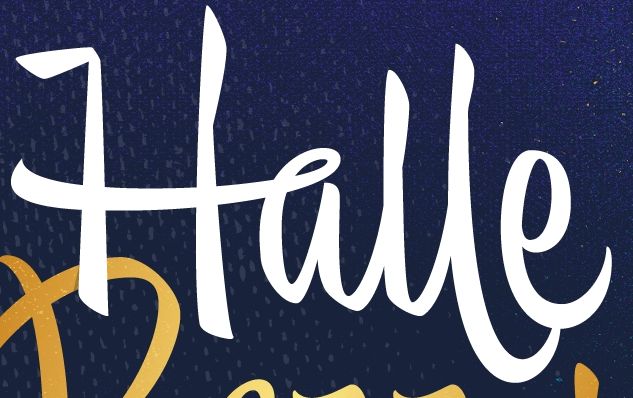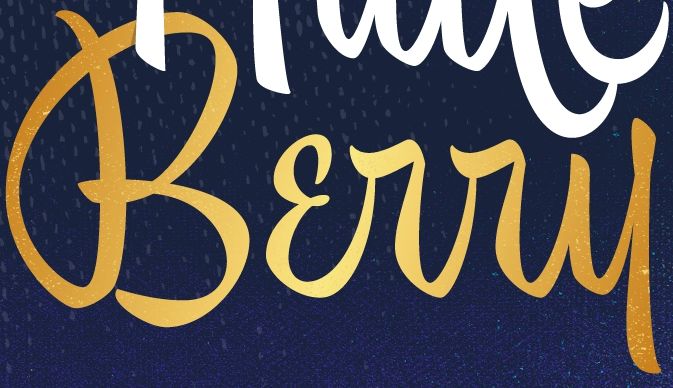Read the text from these images in sequence, separated by a semicolon. Halle; Bɛrry 